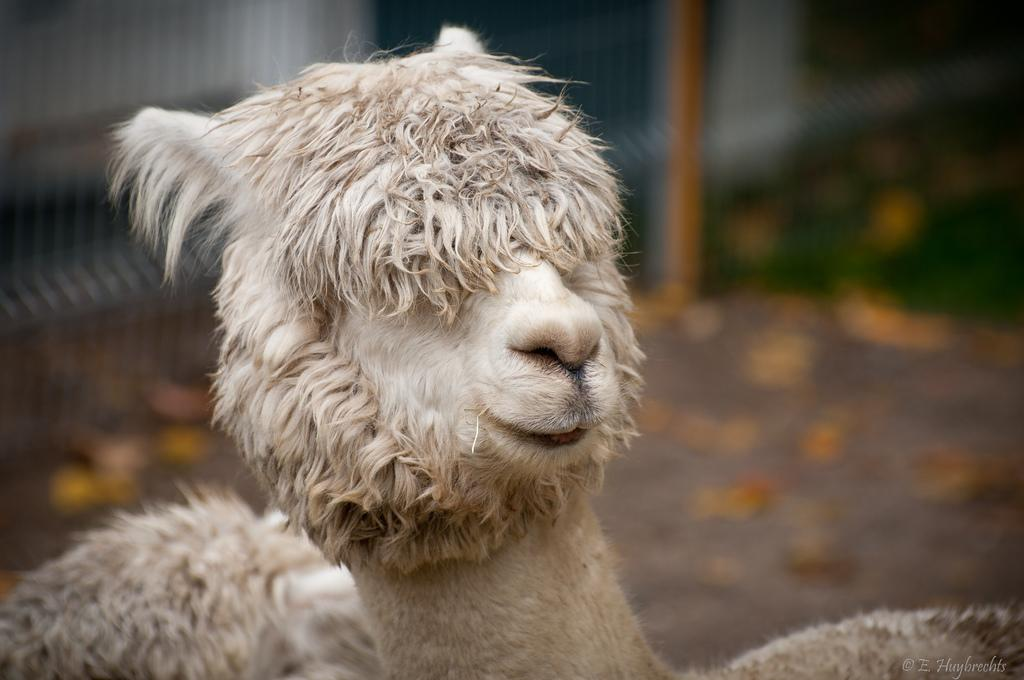How many animals can be seen in the image? There are two animals in the image. What can be seen in the background of the image? There is a fence and grass in the background of the image. Can you describe the quality of the image? The image is blurry. What type of afterthought is being expressed by the scarecrow in the image? There is no scarecrow present in the image, so it is not possible to answer that question. 